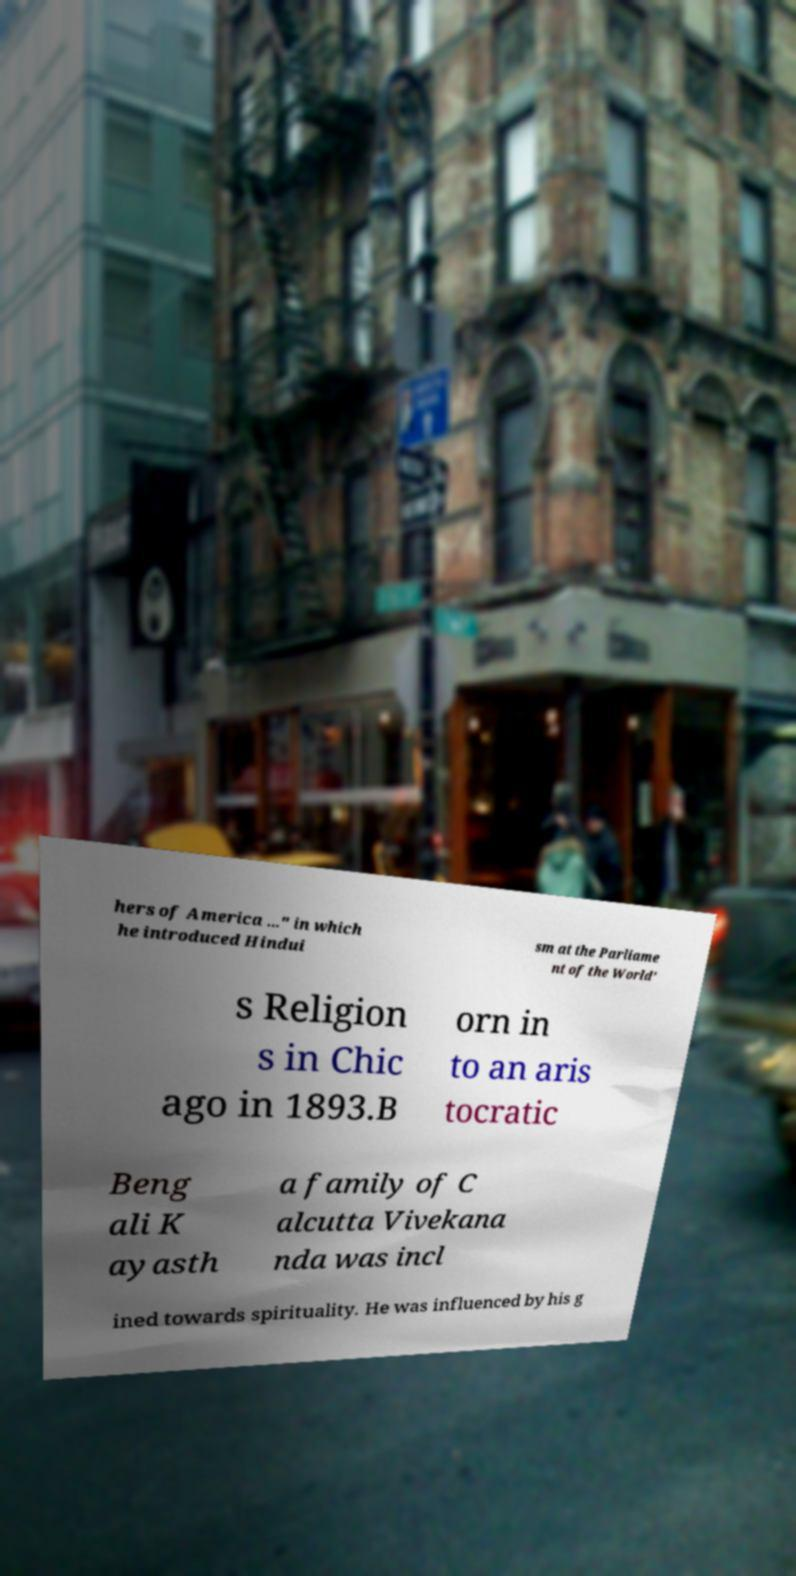Could you extract and type out the text from this image? hers of America ..." in which he introduced Hindui sm at the Parliame nt of the World' s Religion s in Chic ago in 1893.B orn in to an aris tocratic Beng ali K ayasth a family of C alcutta Vivekana nda was incl ined towards spirituality. He was influenced by his g 